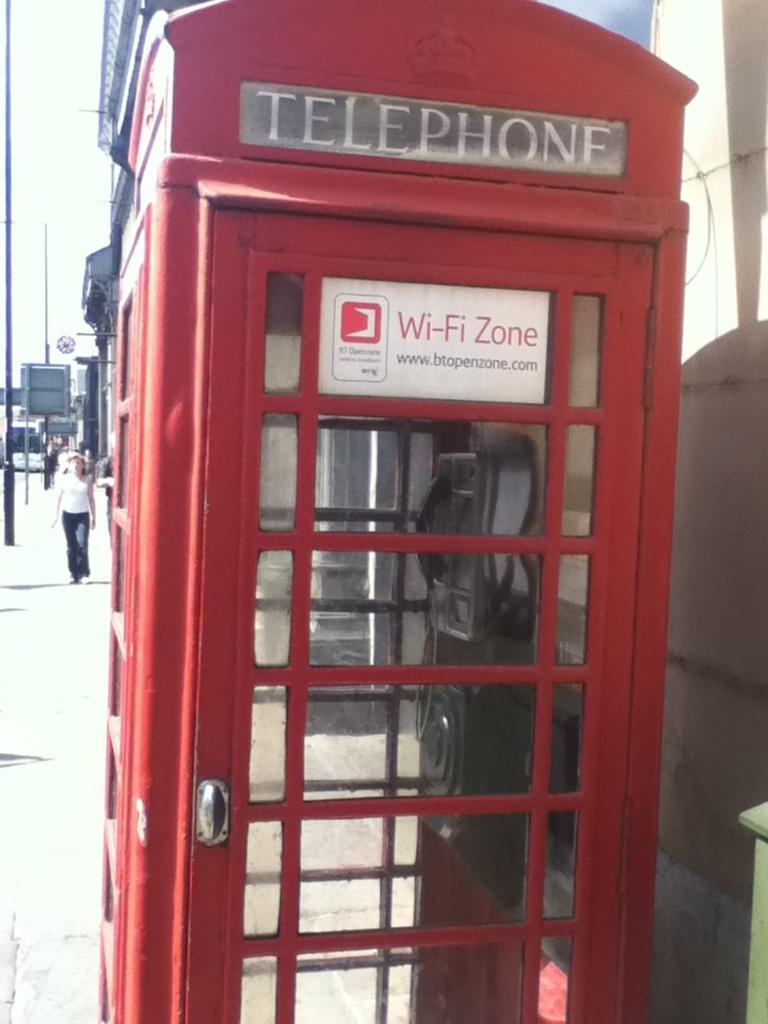What does the white sign say?
Your answer should be very brief. Wi-fi zone. What does the gray sign say?
Make the answer very short. Telephone. 